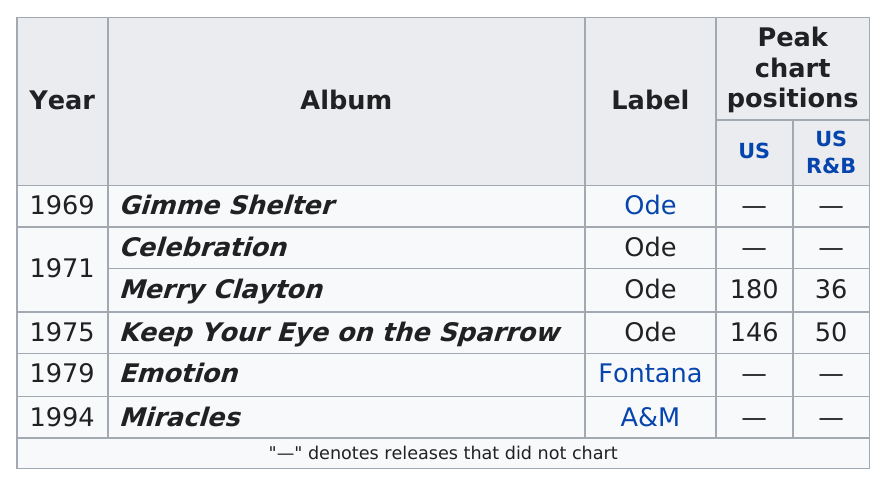Give some essential details in this illustration. In the 1970s, a total of three albums were released. The first album released was 'Gimme Shelter'. In the year 1969, Clayton released his first album. The period between the first and last album in the table is approximately 25 years. The last album was recorded with the label A&M. 